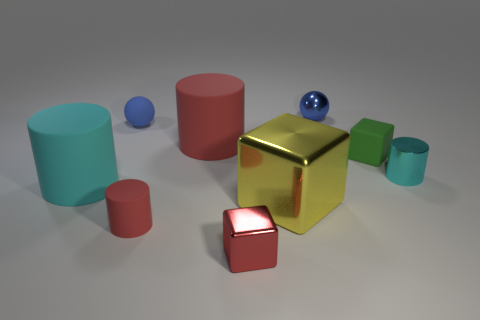Add 1 small metallic things. How many objects exist? 10 Subtract all small cyan cylinders. How many cylinders are left? 3 Subtract all brown cubes. Subtract all red balls. How many cubes are left? 3 Subtract all gray cubes. How many cyan cylinders are left? 2 Subtract all cyan shiny things. Subtract all large cyan cubes. How many objects are left? 8 Add 6 red metallic things. How many red metallic things are left? 7 Add 6 tiny shiny cubes. How many tiny shiny cubes exist? 7 Subtract all red cylinders. How many cylinders are left? 2 Subtract 0 cyan cubes. How many objects are left? 9 Subtract all spheres. How many objects are left? 7 